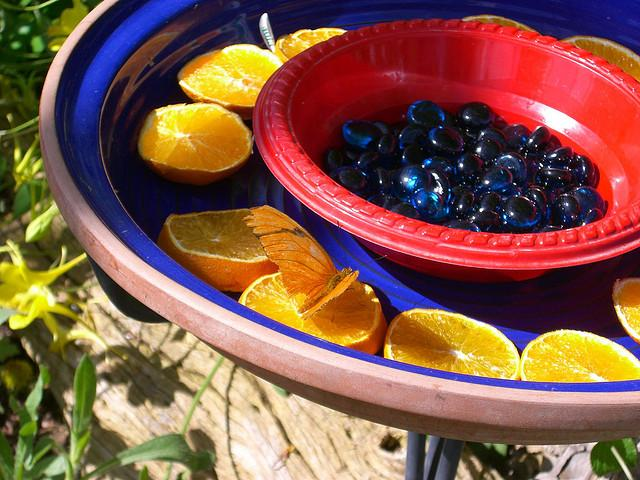What food group is being served? Please explain your reasoning. fruits. The food is a fruit. 